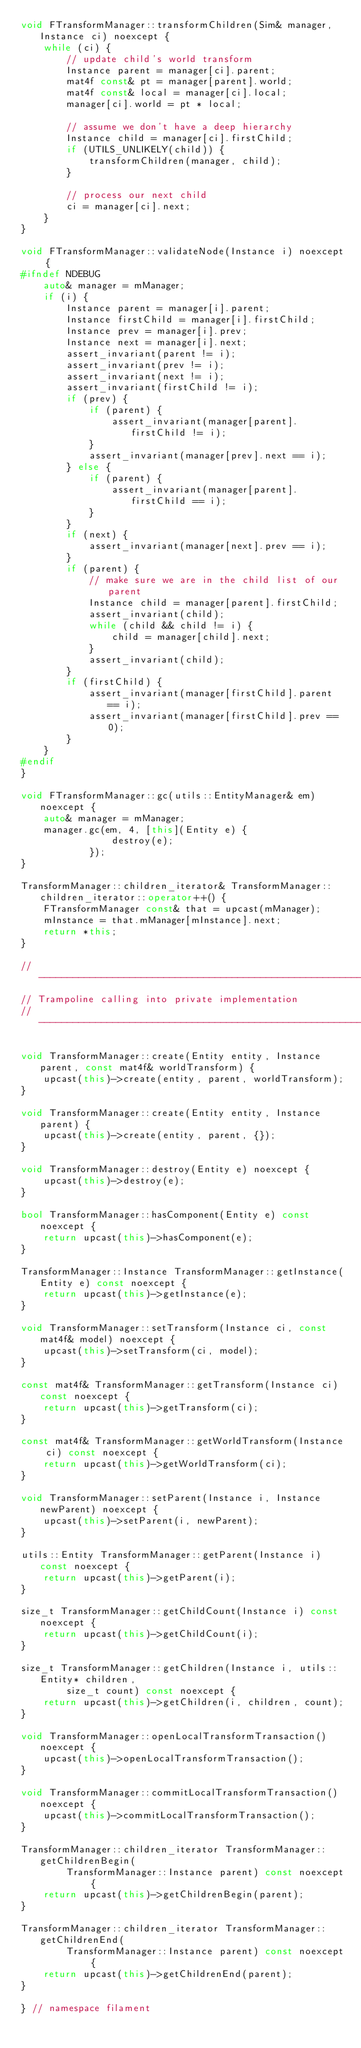Convert code to text. <code><loc_0><loc_0><loc_500><loc_500><_C++_>void FTransformManager::transformChildren(Sim& manager, Instance ci) noexcept {
    while (ci) {
        // update child's world transform
        Instance parent = manager[ci].parent;
        mat4f const& pt = manager[parent].world;
        mat4f const& local = manager[ci].local;
        manager[ci].world = pt * local;

        // assume we don't have a deep hierarchy
        Instance child = manager[ci].firstChild;
        if (UTILS_UNLIKELY(child)) {
            transformChildren(manager, child);
        }

        // process our next child
        ci = manager[ci].next;
    }
}

void FTransformManager::validateNode(Instance i) noexcept {
#ifndef NDEBUG
    auto& manager = mManager;
    if (i) {
        Instance parent = manager[i].parent;
        Instance firstChild = manager[i].firstChild;
        Instance prev = manager[i].prev;
        Instance next = manager[i].next;
        assert_invariant(parent != i);
        assert_invariant(prev != i);
        assert_invariant(next != i);
        assert_invariant(firstChild != i);
        if (prev) {
            if (parent) {
                assert_invariant(manager[parent].firstChild != i);
            }
            assert_invariant(manager[prev].next == i);
        } else {
            if (parent) {
                assert_invariant(manager[parent].firstChild == i);
            }
        }
        if (next) {
            assert_invariant(manager[next].prev == i);
        }
        if (parent) {
            // make sure we are in the child list of our parent
            Instance child = manager[parent].firstChild;
            assert_invariant(child);
            while (child && child != i) {
                child = manager[child].next;
            }
            assert_invariant(child);
        }
        if (firstChild) {
            assert_invariant(manager[firstChild].parent == i);
            assert_invariant(manager[firstChild].prev == 0);
        }
    }
#endif
}

void FTransformManager::gc(utils::EntityManager& em) noexcept {
    auto& manager = mManager;
    manager.gc(em, 4, [this](Entity e) {
                destroy(e);
            });
}

TransformManager::children_iterator& TransformManager::children_iterator::operator++() {
    FTransformManager const& that = upcast(mManager);
    mInstance = that.mManager[mInstance].next;
    return *this;
}

// ------------------------------------------------------------------------------------------------
// Trampoline calling into private implementation
// ------------------------------------------------------------------------------------------------

void TransformManager::create(Entity entity, Instance parent, const mat4f& worldTransform) {
    upcast(this)->create(entity, parent, worldTransform);
}

void TransformManager::create(Entity entity, Instance parent) {
    upcast(this)->create(entity, parent, {});
}

void TransformManager::destroy(Entity e) noexcept {
    upcast(this)->destroy(e);
}

bool TransformManager::hasComponent(Entity e) const noexcept {
    return upcast(this)->hasComponent(e);
}

TransformManager::Instance TransformManager::getInstance(Entity e) const noexcept {
    return upcast(this)->getInstance(e);
}

void TransformManager::setTransform(Instance ci, const mat4f& model) noexcept {
    upcast(this)->setTransform(ci, model);
}

const mat4f& TransformManager::getTransform(Instance ci) const noexcept {
    return upcast(this)->getTransform(ci);
}

const mat4f& TransformManager::getWorldTransform(Instance ci) const noexcept {
    return upcast(this)->getWorldTransform(ci);
}

void TransformManager::setParent(Instance i, Instance newParent) noexcept {
    upcast(this)->setParent(i, newParent);
}

utils::Entity TransformManager::getParent(Instance i) const noexcept {
    return upcast(this)->getParent(i);
}

size_t TransformManager::getChildCount(Instance i) const noexcept {
    return upcast(this)->getChildCount(i);
}

size_t TransformManager::getChildren(Instance i, utils::Entity* children,
        size_t count) const noexcept {
    return upcast(this)->getChildren(i, children, count);
}

void TransformManager::openLocalTransformTransaction() noexcept {
    upcast(this)->openLocalTransformTransaction();
}

void TransformManager::commitLocalTransformTransaction() noexcept {
    upcast(this)->commitLocalTransformTransaction();
}

TransformManager::children_iterator TransformManager::getChildrenBegin(
        TransformManager::Instance parent) const noexcept {
    return upcast(this)->getChildrenBegin(parent);
}

TransformManager::children_iterator TransformManager::getChildrenEnd(
        TransformManager::Instance parent) const noexcept {
    return upcast(this)->getChildrenEnd(parent);
}

} // namespace filament
</code> 